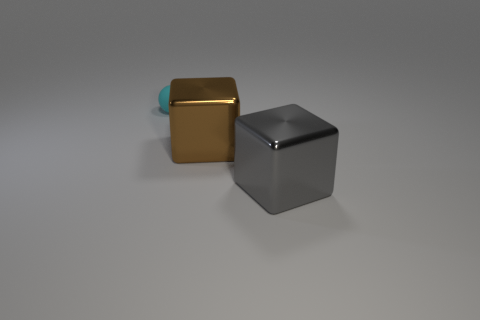Is there anything else that has the same size as the rubber thing?
Ensure brevity in your answer.  No. Does the thing left of the brown shiny cube have the same size as the large gray shiny block?
Your answer should be very brief. No. Are there fewer cyan matte spheres than large yellow cylinders?
Keep it short and to the point. No. There is a tiny cyan matte thing; what number of cyan matte objects are behind it?
Offer a very short reply. 0. Is the large brown object the same shape as the gray object?
Offer a very short reply. Yes. How many things are both to the left of the large gray object and in front of the small rubber ball?
Offer a terse response. 1. What number of things are large metal cubes or tiny matte things that are behind the gray shiny block?
Give a very brief answer. 3. Are there more cubes than brown shiny objects?
Keep it short and to the point. Yes. What is the shape of the big metal thing that is to the left of the large gray object?
Provide a succinct answer. Cube. How many gray things are the same shape as the cyan object?
Offer a terse response. 0. 